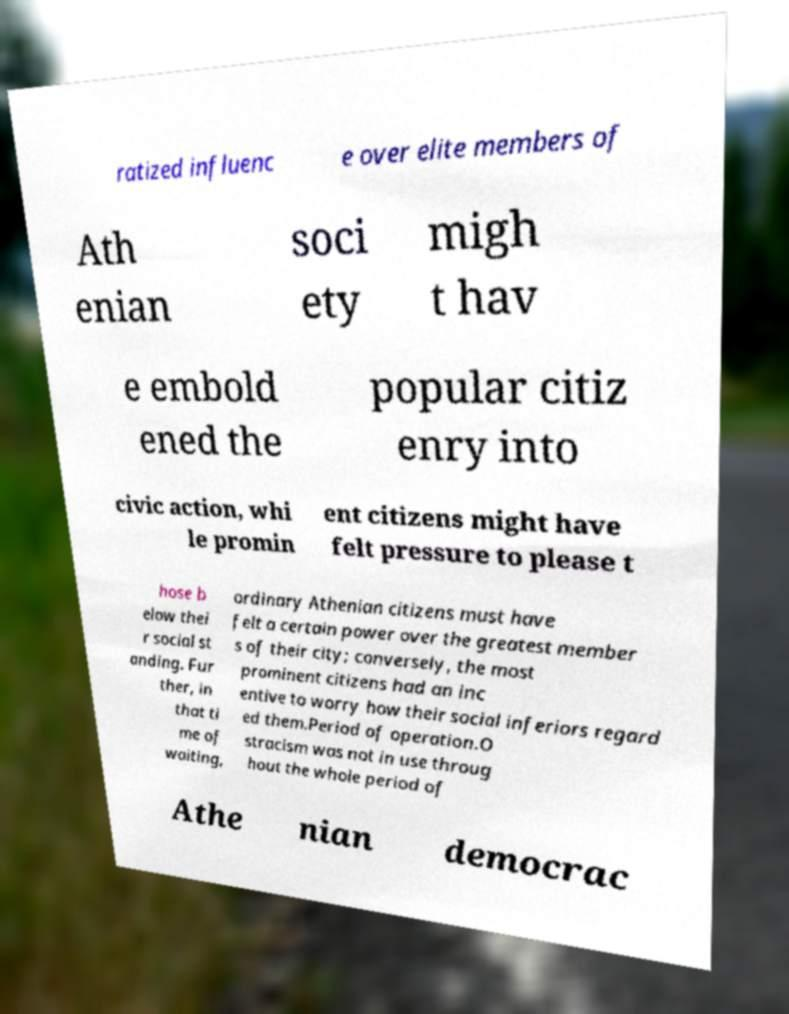Please identify and transcribe the text found in this image. ratized influenc e over elite members of Ath enian soci ety migh t hav e embold ened the popular citiz enry into civic action, whi le promin ent citizens might have felt pressure to please t hose b elow thei r social st anding. Fur ther, in that ti me of waiting, ordinary Athenian citizens must have felt a certain power over the greatest member s of their city; conversely, the most prominent citizens had an inc entive to worry how their social inferiors regard ed them.Period of operation.O stracism was not in use throug hout the whole period of Athe nian democrac 